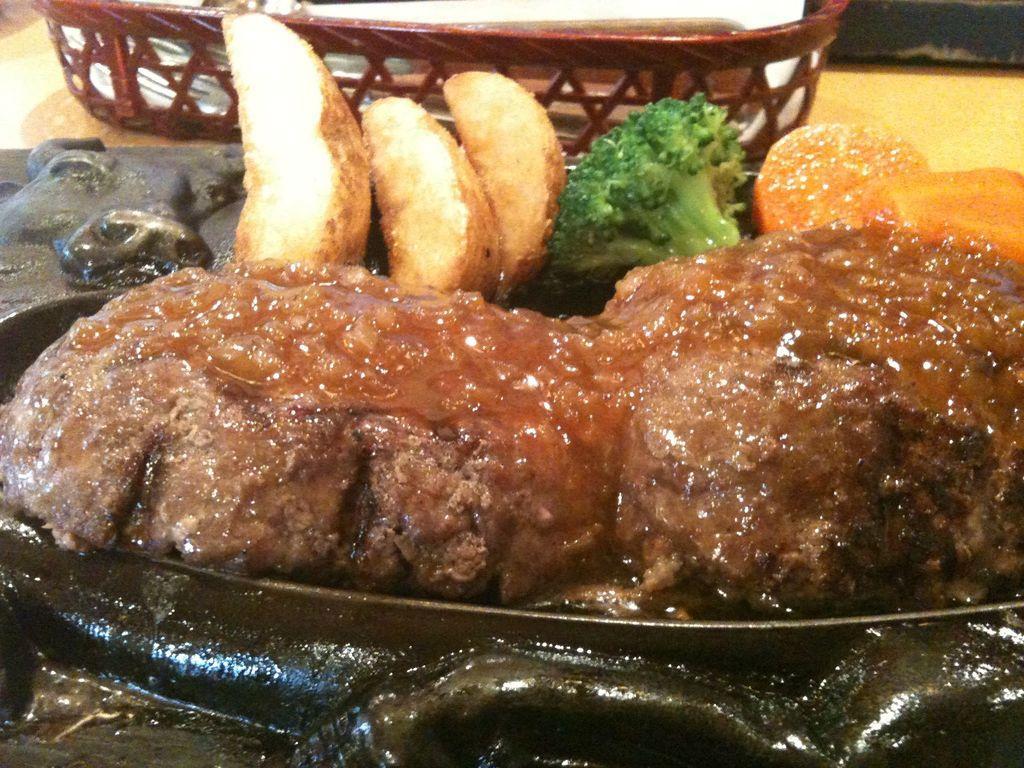In one or two sentences, can you explain what this image depicts? In the image there are some cooked food items and broccoli served in a plate. 